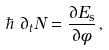Convert formula to latex. <formula><loc_0><loc_0><loc_500><loc_500>\hbar { \, } \, \partial _ { t } N = \frac { \partial E _ { \text  s}}{\partial\phi}\, ,</formula> 